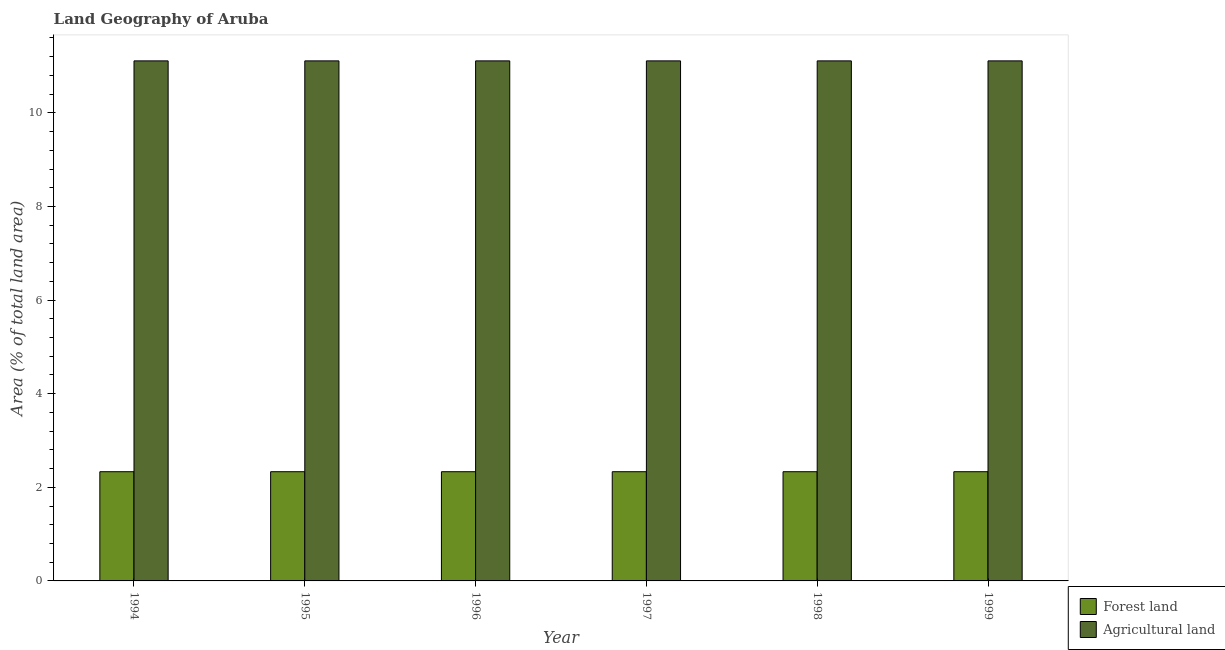How many different coloured bars are there?
Give a very brief answer. 2. How many groups of bars are there?
Your answer should be compact. 6. Are the number of bars per tick equal to the number of legend labels?
Offer a terse response. Yes. Are the number of bars on each tick of the X-axis equal?
Give a very brief answer. Yes. How many bars are there on the 3rd tick from the left?
Offer a very short reply. 2. How many bars are there on the 1st tick from the right?
Provide a succinct answer. 2. What is the label of the 4th group of bars from the left?
Give a very brief answer. 1997. In how many cases, is the number of bars for a given year not equal to the number of legend labels?
Make the answer very short. 0. What is the percentage of land area under forests in 1998?
Make the answer very short. 2.33. Across all years, what is the maximum percentage of land area under forests?
Make the answer very short. 2.33. Across all years, what is the minimum percentage of land area under agriculture?
Make the answer very short. 11.11. In which year was the percentage of land area under agriculture minimum?
Provide a succinct answer. 1994. What is the total percentage of land area under forests in the graph?
Offer a terse response. 14. What is the difference between the percentage of land area under forests in 1995 and that in 1999?
Your answer should be very brief. 0. What is the average percentage of land area under forests per year?
Make the answer very short. 2.33. In the year 1995, what is the difference between the percentage of land area under agriculture and percentage of land area under forests?
Offer a terse response. 0. What is the ratio of the percentage of land area under forests in 1996 to that in 1999?
Your answer should be compact. 1. Is the percentage of land area under forests in 1996 less than that in 1999?
Ensure brevity in your answer.  No. What is the difference between the highest and the second highest percentage of land area under forests?
Your response must be concise. 0. What is the difference between the highest and the lowest percentage of land area under agriculture?
Make the answer very short. 0. What does the 2nd bar from the left in 1994 represents?
Provide a succinct answer. Agricultural land. What does the 2nd bar from the right in 1999 represents?
Offer a very short reply. Forest land. How many bars are there?
Provide a succinct answer. 12. How many years are there in the graph?
Make the answer very short. 6. What is the difference between two consecutive major ticks on the Y-axis?
Keep it short and to the point. 2. Where does the legend appear in the graph?
Offer a terse response. Bottom right. What is the title of the graph?
Your answer should be very brief. Land Geography of Aruba. Does "Quasi money growth" appear as one of the legend labels in the graph?
Your answer should be compact. No. What is the label or title of the Y-axis?
Offer a terse response. Area (% of total land area). What is the Area (% of total land area) of Forest land in 1994?
Offer a very short reply. 2.33. What is the Area (% of total land area) in Agricultural land in 1994?
Ensure brevity in your answer.  11.11. What is the Area (% of total land area) in Forest land in 1995?
Your answer should be very brief. 2.33. What is the Area (% of total land area) in Agricultural land in 1995?
Keep it short and to the point. 11.11. What is the Area (% of total land area) of Forest land in 1996?
Make the answer very short. 2.33. What is the Area (% of total land area) of Agricultural land in 1996?
Your response must be concise. 11.11. What is the Area (% of total land area) of Forest land in 1997?
Keep it short and to the point. 2.33. What is the Area (% of total land area) of Agricultural land in 1997?
Provide a succinct answer. 11.11. What is the Area (% of total land area) of Forest land in 1998?
Offer a terse response. 2.33. What is the Area (% of total land area) in Agricultural land in 1998?
Ensure brevity in your answer.  11.11. What is the Area (% of total land area) in Forest land in 1999?
Ensure brevity in your answer.  2.33. What is the Area (% of total land area) of Agricultural land in 1999?
Your answer should be compact. 11.11. Across all years, what is the maximum Area (% of total land area) of Forest land?
Keep it short and to the point. 2.33. Across all years, what is the maximum Area (% of total land area) in Agricultural land?
Keep it short and to the point. 11.11. Across all years, what is the minimum Area (% of total land area) of Forest land?
Make the answer very short. 2.33. Across all years, what is the minimum Area (% of total land area) in Agricultural land?
Your answer should be very brief. 11.11. What is the total Area (% of total land area) of Agricultural land in the graph?
Provide a succinct answer. 66.67. What is the difference between the Area (% of total land area) of Forest land in 1994 and that in 1995?
Your answer should be compact. 0. What is the difference between the Area (% of total land area) in Forest land in 1994 and that in 1996?
Your answer should be compact. 0. What is the difference between the Area (% of total land area) in Agricultural land in 1994 and that in 1996?
Provide a short and direct response. 0. What is the difference between the Area (% of total land area) in Forest land in 1994 and that in 1998?
Offer a very short reply. 0. What is the difference between the Area (% of total land area) of Agricultural land in 1994 and that in 1998?
Your answer should be very brief. 0. What is the difference between the Area (% of total land area) of Forest land in 1994 and that in 1999?
Your answer should be compact. 0. What is the difference between the Area (% of total land area) of Agricultural land in 1995 and that in 1996?
Offer a terse response. 0. What is the difference between the Area (% of total land area) of Forest land in 1995 and that in 1997?
Offer a very short reply. 0. What is the difference between the Area (% of total land area) in Agricultural land in 1995 and that in 1997?
Your response must be concise. 0. What is the difference between the Area (% of total land area) of Agricultural land in 1996 and that in 1997?
Offer a very short reply. 0. What is the difference between the Area (% of total land area) in Forest land in 1996 and that in 1998?
Keep it short and to the point. 0. What is the difference between the Area (% of total land area) in Agricultural land in 1996 and that in 1998?
Give a very brief answer. 0. What is the difference between the Area (% of total land area) in Forest land in 1996 and that in 1999?
Your response must be concise. 0. What is the difference between the Area (% of total land area) of Agricultural land in 1997 and that in 1999?
Ensure brevity in your answer.  0. What is the difference between the Area (% of total land area) of Forest land in 1998 and that in 1999?
Keep it short and to the point. 0. What is the difference between the Area (% of total land area) of Agricultural land in 1998 and that in 1999?
Offer a terse response. 0. What is the difference between the Area (% of total land area) in Forest land in 1994 and the Area (% of total land area) in Agricultural land in 1995?
Your response must be concise. -8.78. What is the difference between the Area (% of total land area) of Forest land in 1994 and the Area (% of total land area) of Agricultural land in 1996?
Your response must be concise. -8.78. What is the difference between the Area (% of total land area) in Forest land in 1994 and the Area (% of total land area) in Agricultural land in 1997?
Keep it short and to the point. -8.78. What is the difference between the Area (% of total land area) of Forest land in 1994 and the Area (% of total land area) of Agricultural land in 1998?
Offer a very short reply. -8.78. What is the difference between the Area (% of total land area) in Forest land in 1994 and the Area (% of total land area) in Agricultural land in 1999?
Your answer should be very brief. -8.78. What is the difference between the Area (% of total land area) of Forest land in 1995 and the Area (% of total land area) of Agricultural land in 1996?
Keep it short and to the point. -8.78. What is the difference between the Area (% of total land area) in Forest land in 1995 and the Area (% of total land area) in Agricultural land in 1997?
Make the answer very short. -8.78. What is the difference between the Area (% of total land area) of Forest land in 1995 and the Area (% of total land area) of Agricultural land in 1998?
Make the answer very short. -8.78. What is the difference between the Area (% of total land area) of Forest land in 1995 and the Area (% of total land area) of Agricultural land in 1999?
Your answer should be compact. -8.78. What is the difference between the Area (% of total land area) of Forest land in 1996 and the Area (% of total land area) of Agricultural land in 1997?
Keep it short and to the point. -8.78. What is the difference between the Area (% of total land area) of Forest land in 1996 and the Area (% of total land area) of Agricultural land in 1998?
Your answer should be compact. -8.78. What is the difference between the Area (% of total land area) of Forest land in 1996 and the Area (% of total land area) of Agricultural land in 1999?
Your answer should be very brief. -8.78. What is the difference between the Area (% of total land area) of Forest land in 1997 and the Area (% of total land area) of Agricultural land in 1998?
Keep it short and to the point. -8.78. What is the difference between the Area (% of total land area) in Forest land in 1997 and the Area (% of total land area) in Agricultural land in 1999?
Offer a terse response. -8.78. What is the difference between the Area (% of total land area) of Forest land in 1998 and the Area (% of total land area) of Agricultural land in 1999?
Offer a terse response. -8.78. What is the average Area (% of total land area) in Forest land per year?
Offer a terse response. 2.33. What is the average Area (% of total land area) of Agricultural land per year?
Your response must be concise. 11.11. In the year 1994, what is the difference between the Area (% of total land area) of Forest land and Area (% of total land area) of Agricultural land?
Your answer should be compact. -8.78. In the year 1995, what is the difference between the Area (% of total land area) in Forest land and Area (% of total land area) in Agricultural land?
Offer a terse response. -8.78. In the year 1996, what is the difference between the Area (% of total land area) of Forest land and Area (% of total land area) of Agricultural land?
Your answer should be compact. -8.78. In the year 1997, what is the difference between the Area (% of total land area) of Forest land and Area (% of total land area) of Agricultural land?
Your answer should be compact. -8.78. In the year 1998, what is the difference between the Area (% of total land area) of Forest land and Area (% of total land area) of Agricultural land?
Your answer should be very brief. -8.78. In the year 1999, what is the difference between the Area (% of total land area) in Forest land and Area (% of total land area) in Agricultural land?
Your answer should be compact. -8.78. What is the ratio of the Area (% of total land area) in Forest land in 1994 to that in 1996?
Your response must be concise. 1. What is the ratio of the Area (% of total land area) of Forest land in 1994 to that in 1997?
Make the answer very short. 1. What is the ratio of the Area (% of total land area) in Forest land in 1994 to that in 1998?
Provide a short and direct response. 1. What is the ratio of the Area (% of total land area) in Forest land in 1995 to that in 1997?
Your answer should be compact. 1. What is the ratio of the Area (% of total land area) in Forest land in 1996 to that in 1997?
Give a very brief answer. 1. What is the ratio of the Area (% of total land area) of Forest land in 1996 to that in 1998?
Provide a short and direct response. 1. What is the ratio of the Area (% of total land area) in Agricultural land in 1996 to that in 1998?
Offer a very short reply. 1. What is the ratio of the Area (% of total land area) in Forest land in 1996 to that in 1999?
Give a very brief answer. 1. What is the ratio of the Area (% of total land area) of Agricultural land in 1996 to that in 1999?
Provide a succinct answer. 1. What is the ratio of the Area (% of total land area) in Forest land in 1997 to that in 1998?
Ensure brevity in your answer.  1. What is the ratio of the Area (% of total land area) of Agricultural land in 1997 to that in 1998?
Keep it short and to the point. 1. What is the ratio of the Area (% of total land area) of Forest land in 1997 to that in 1999?
Offer a terse response. 1. What is the ratio of the Area (% of total land area) in Agricultural land in 1998 to that in 1999?
Your answer should be very brief. 1. What is the difference between the highest and the lowest Area (% of total land area) in Forest land?
Keep it short and to the point. 0. What is the difference between the highest and the lowest Area (% of total land area) of Agricultural land?
Provide a succinct answer. 0. 